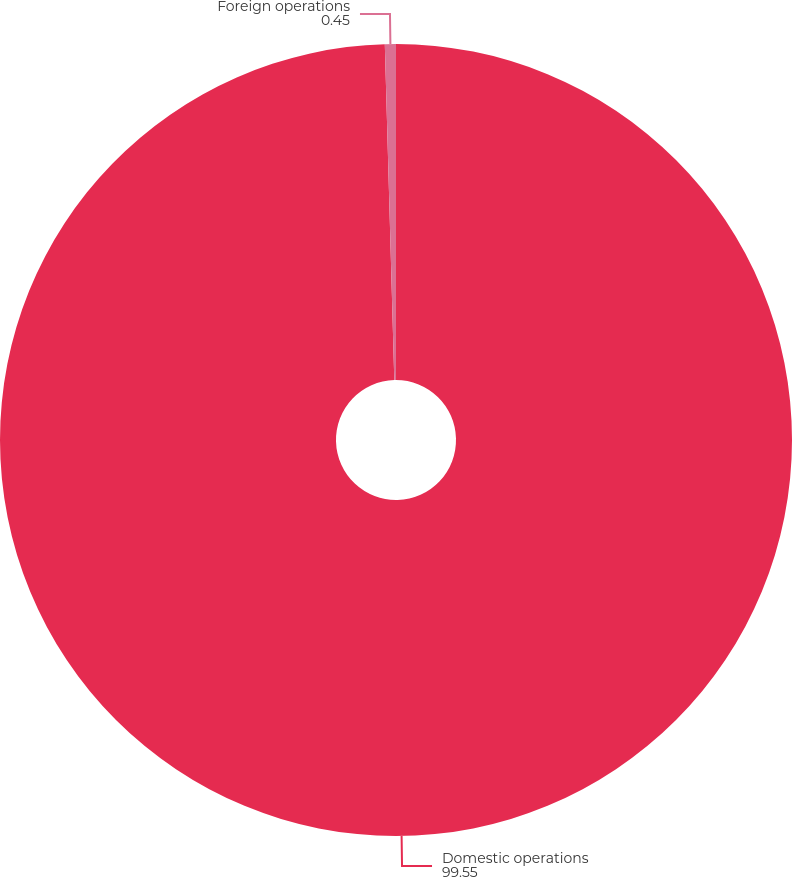<chart> <loc_0><loc_0><loc_500><loc_500><pie_chart><fcel>Domestic operations<fcel>Foreign operations<nl><fcel>99.55%<fcel>0.45%<nl></chart> 